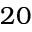Convert formula to latex. <formula><loc_0><loc_0><loc_500><loc_500>2 0</formula> 